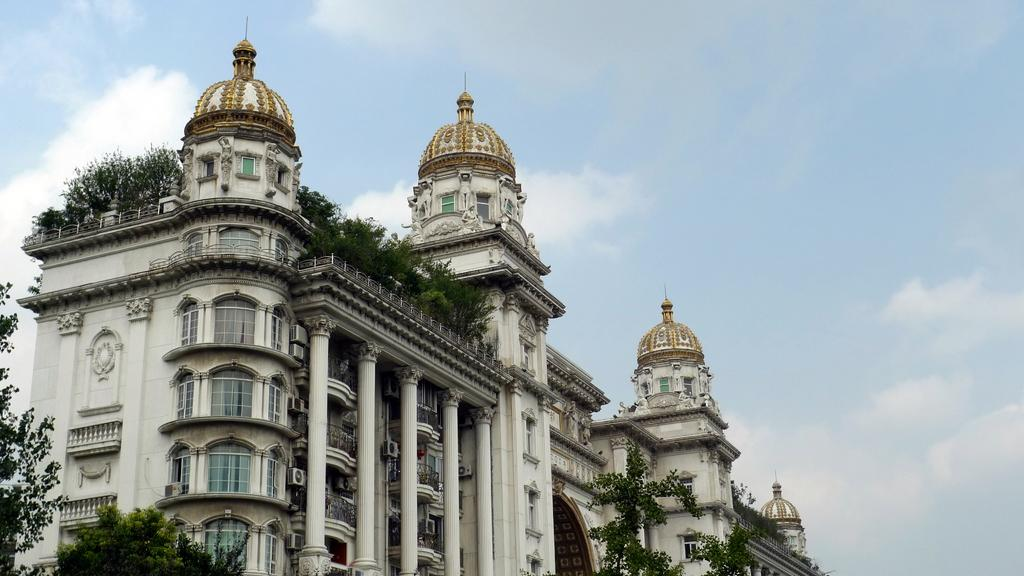What type of structure is present in the image? There is a building in the image. What is the color of the building? The building is cream in color. What can be seen around the building? There are trees around the building. Are there any plants on the building? Yes, there are plants on the building. What is visible in the background of the image? The sky is visible in the background of the image. Can you find the receipt for the purchase of the building in the image? There is no receipt present in the image, as it is a photograph of a building and not a record of a transaction. 